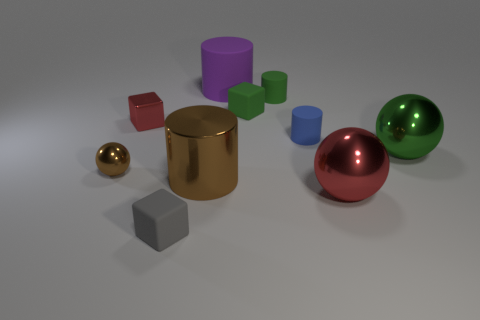There is a tiny blue thing that is the same material as the gray object; what shape is it?
Give a very brief answer. Cylinder. There is a big rubber cylinder; does it have the same color as the tiny matte cylinder behind the tiny blue rubber cylinder?
Keep it short and to the point. No. How many balls are big blue metallic objects or green matte objects?
Offer a terse response. 0. What is the color of the small cylinder that is in front of the tiny metal cube?
Your response must be concise. Blue. What shape is the large shiny thing that is the same color as the tiny ball?
Offer a very short reply. Cylinder. How many red metal cubes are the same size as the gray rubber cube?
Your answer should be compact. 1. Do the small shiny thing that is in front of the blue rubber cylinder and the big metallic thing that is left of the big rubber cylinder have the same shape?
Give a very brief answer. No. What is the material of the cylinder in front of the green ball that is right of the matte cube behind the big red metallic ball?
Provide a succinct answer. Metal. What is the shape of the brown object that is the same size as the blue cylinder?
Your answer should be very brief. Sphere. Are there any large shiny objects that have the same color as the tiny metal cube?
Make the answer very short. Yes. 